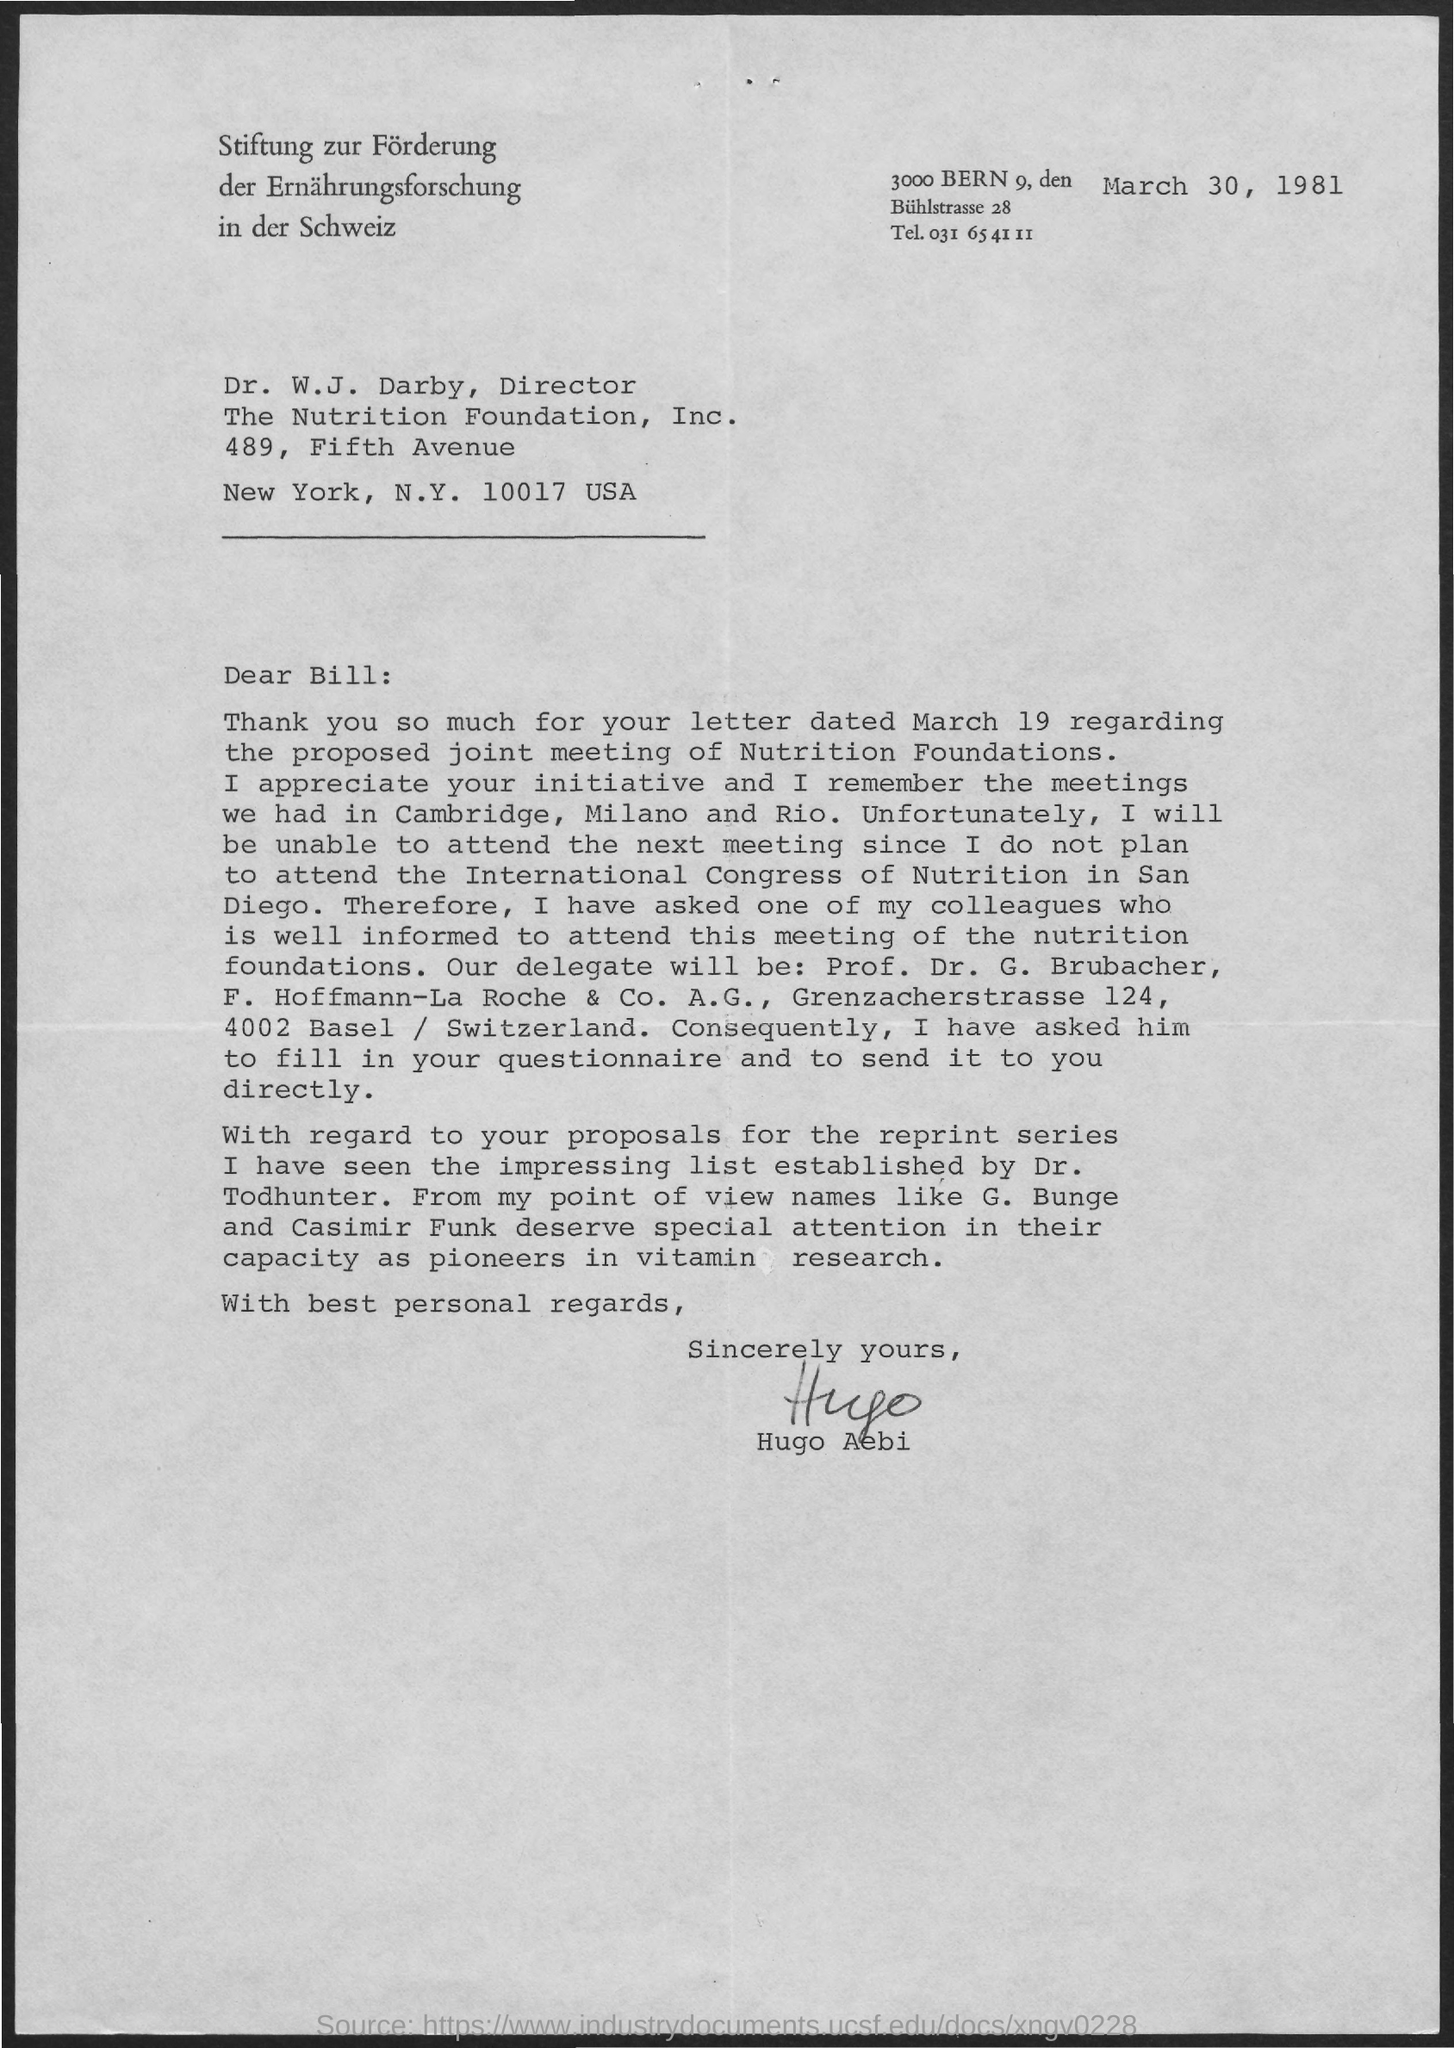Draw attention to some important aspects in this diagram. The memorandum was dated on March 30, 1981. 